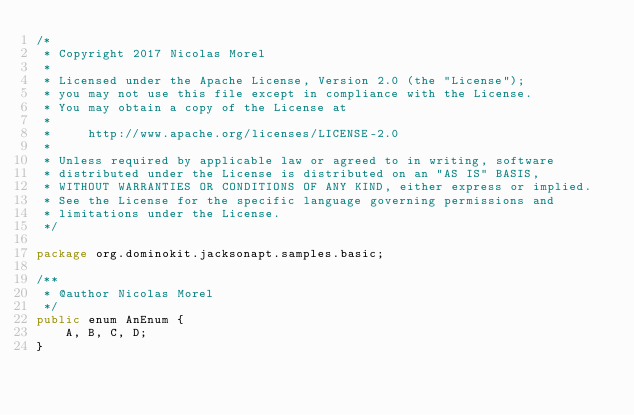Convert code to text. <code><loc_0><loc_0><loc_500><loc_500><_Java_>/*
 * Copyright 2017 Nicolas Morel
 *
 * Licensed under the Apache License, Version 2.0 (the "License");
 * you may not use this file except in compliance with the License.
 * You may obtain a copy of the License at
 *
 *     http://www.apache.org/licenses/LICENSE-2.0
 *
 * Unless required by applicable law or agreed to in writing, software
 * distributed under the License is distributed on an "AS IS" BASIS,
 * WITHOUT WARRANTIES OR CONDITIONS OF ANY KIND, either express or implied.
 * See the License for the specific language governing permissions and
 * limitations under the License.
 */

package org.dominokit.jacksonapt.samples.basic;

/**
 * @author Nicolas Morel
 */
public enum AnEnum {
    A, B, C, D;
}
</code> 